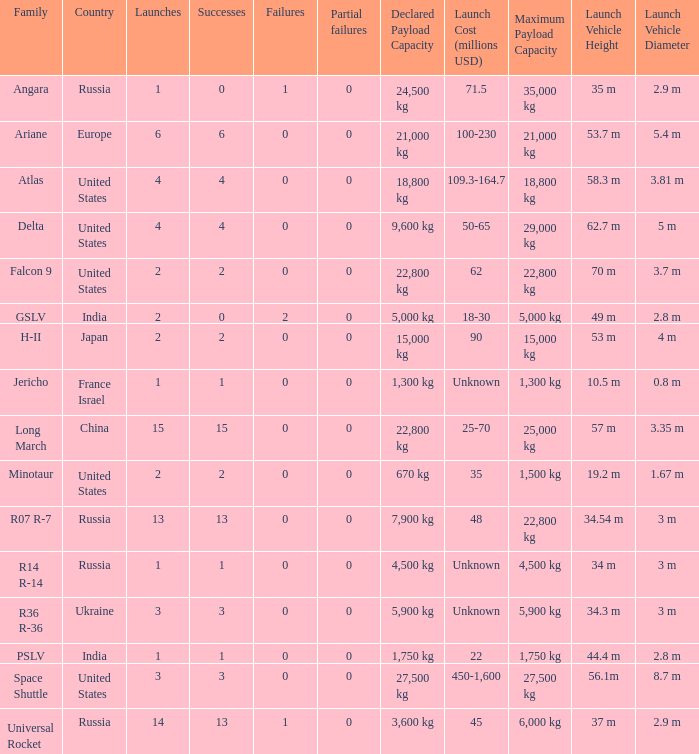What is the number of failure for the country of Russia, and a Family of r14 r-14, and a Partial failures smaller than 0? 0.0. 